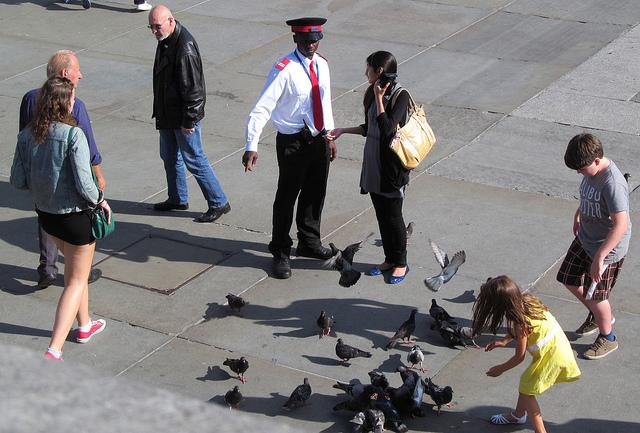What does the girl in yellow do to the birds? feed them 